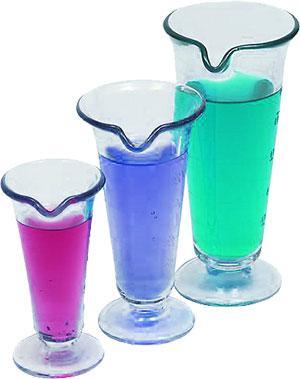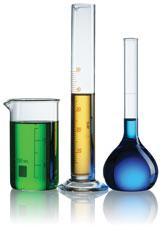The first image is the image on the left, the second image is the image on the right. Examine the images to the left and right. Is the description "An image shows an angled row of three of the same type of container shapes, with different colored liquids inside." accurate? Answer yes or no. Yes. The first image is the image on the left, the second image is the image on the right. For the images displayed, is the sentence "Four vases in the image on the left are filled with blue liquid." factually correct? Answer yes or no. No. 